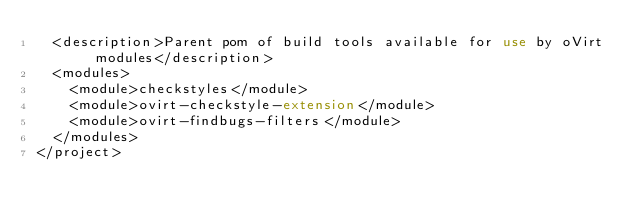Convert code to text. <code><loc_0><loc_0><loc_500><loc_500><_XML_>  <description>Parent pom of build tools available for use by oVirt modules</description>
  <modules>
    <module>checkstyles</module>
    <module>ovirt-checkstyle-extension</module>
    <module>ovirt-findbugs-filters</module>
  </modules>
</project>
</code> 